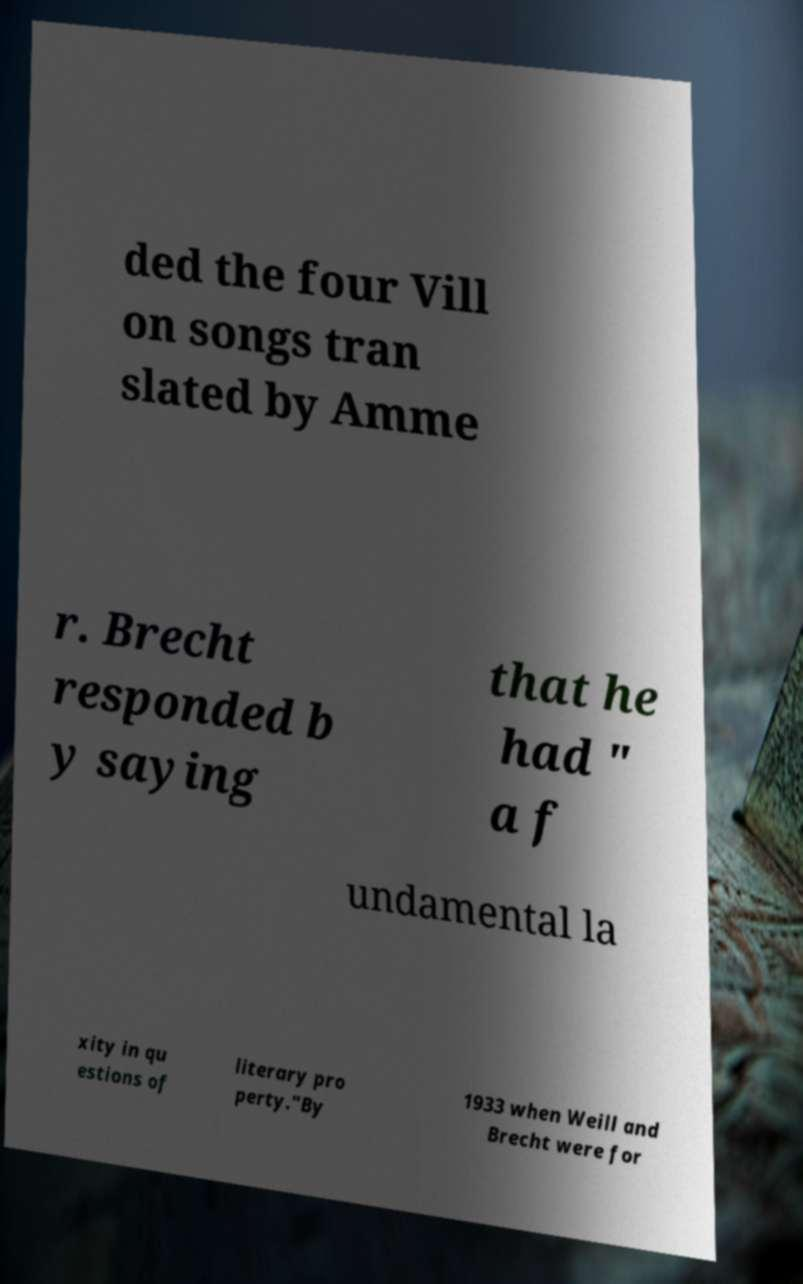I need the written content from this picture converted into text. Can you do that? ded the four Vill on songs tran slated by Amme r. Brecht responded b y saying that he had " a f undamental la xity in qu estions of literary pro perty."By 1933 when Weill and Brecht were for 